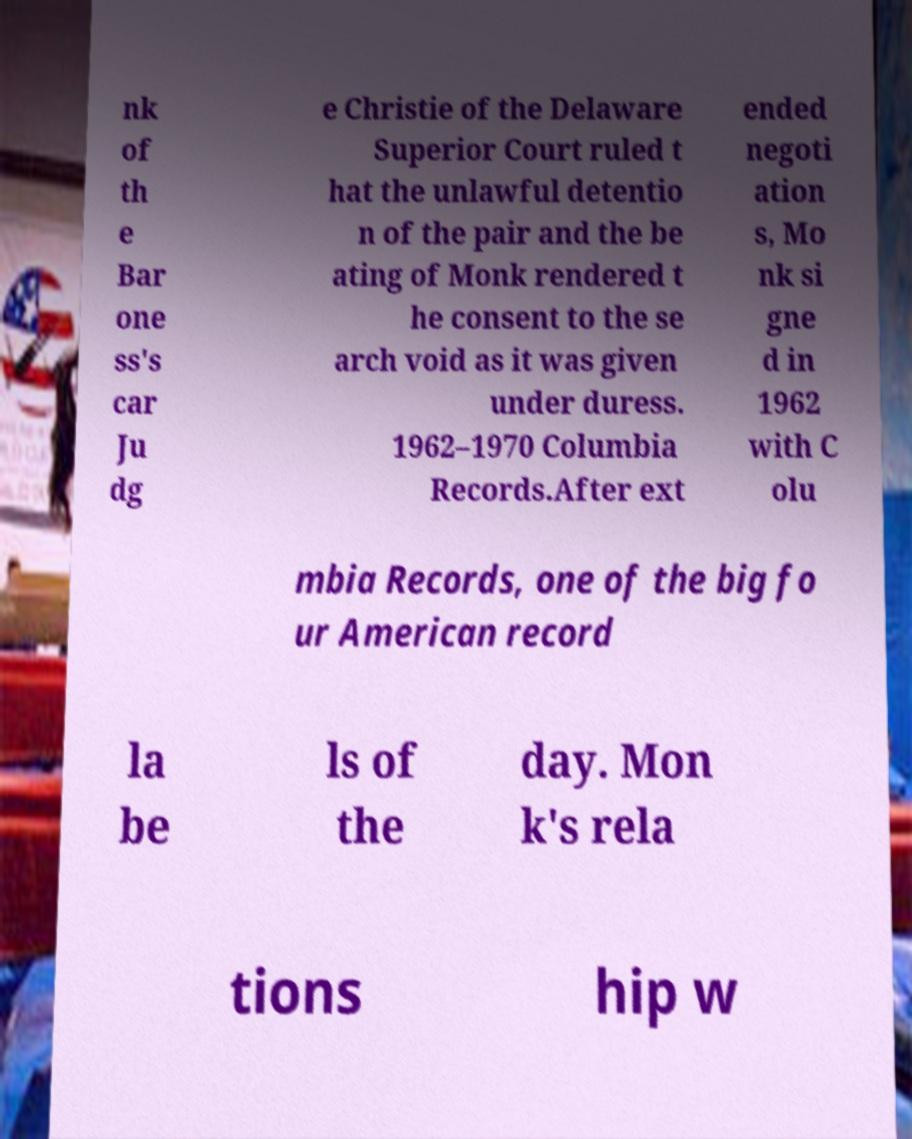Can you read and provide the text displayed in the image?This photo seems to have some interesting text. Can you extract and type it out for me? nk of th e Bar one ss's car Ju dg e Christie of the Delaware Superior Court ruled t hat the unlawful detentio n of the pair and the be ating of Monk rendered t he consent to the se arch void as it was given under duress. 1962–1970 Columbia Records.After ext ended negoti ation s, Mo nk si gne d in 1962 with C olu mbia Records, one of the big fo ur American record la be ls of the day. Mon k's rela tions hip w 